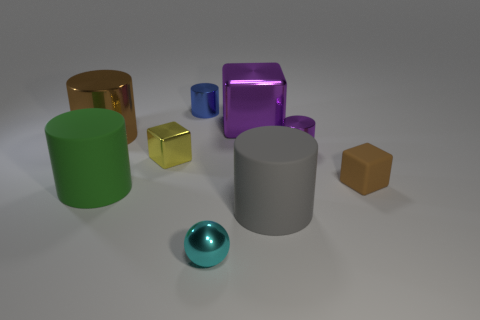The small cube on the left side of the small object behind the big metallic object that is to the left of the yellow cube is made of what material?
Ensure brevity in your answer.  Metal. The small shiny cube has what color?
Provide a succinct answer. Yellow. How many big things are either rubber cubes or green metallic blocks?
Offer a terse response. 0. There is a thing that is the same color as the small rubber cube; what is it made of?
Provide a short and direct response. Metal. Is the big cylinder that is in front of the large green cylinder made of the same material as the block that is on the right side of the large purple thing?
Make the answer very short. Yes. Are any tiny blue metal cylinders visible?
Your answer should be compact. Yes. Is the number of blue cylinders that are in front of the gray thing greater than the number of green matte cylinders to the right of the small cyan shiny sphere?
Provide a short and direct response. No. There is a large gray object that is the same shape as the green object; what is it made of?
Make the answer very short. Rubber. Are there any other things that are the same size as the metallic ball?
Ensure brevity in your answer.  Yes. Does the tiny shiny thing that is in front of the yellow shiny block have the same color as the tiny metal thing to the right of the big purple thing?
Your answer should be very brief. No. 